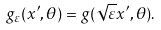Convert formula to latex. <formula><loc_0><loc_0><loc_500><loc_500>g _ { \varepsilon } ( x ^ { \prime } , \theta ) = g ( \sqrt { \varepsilon } x ^ { \prime } , \theta ) .</formula> 